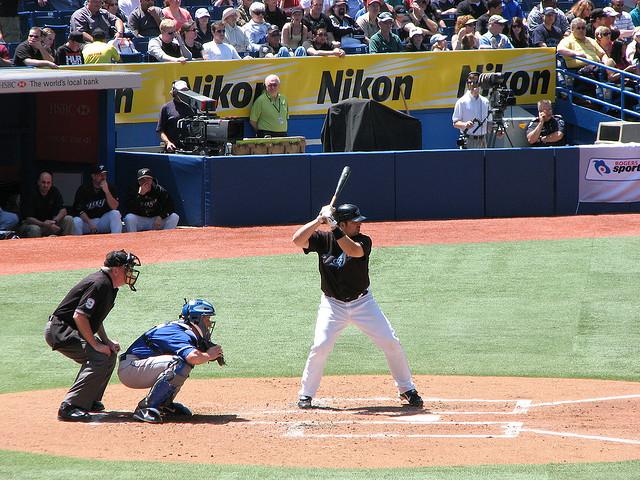Who is sponsoring this event?
Give a very brief answer. Nikon. What is the person behind the catcher called?
Quick response, please. Umpire. Is this game being televised?
Keep it brief. Yes. 